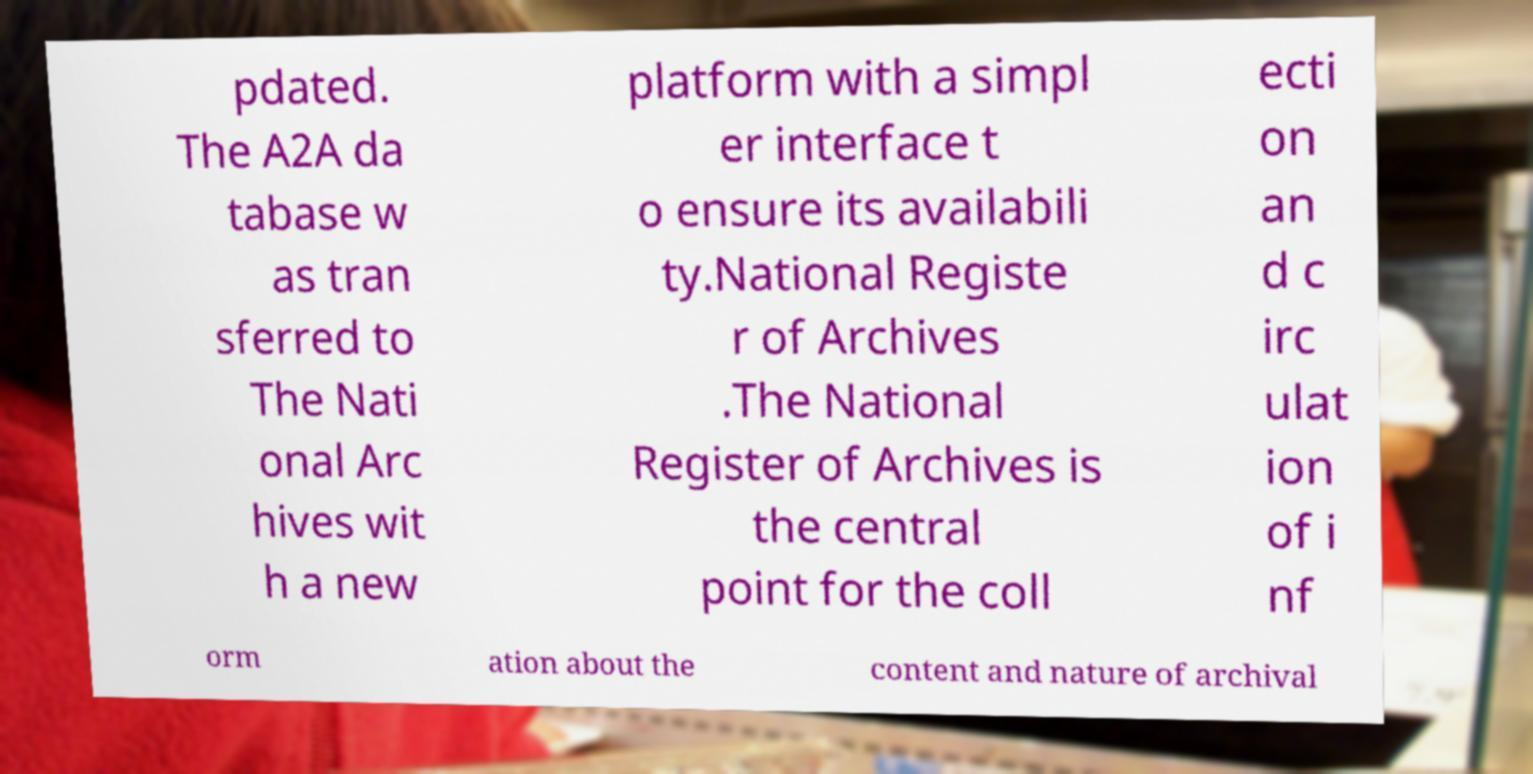I need the written content from this picture converted into text. Can you do that? pdated. The A2A da tabase w as tran sferred to The Nati onal Arc hives wit h a new platform with a simpl er interface t o ensure its availabili ty.National Registe r of Archives .The National Register of Archives is the central point for the coll ecti on an d c irc ulat ion of i nf orm ation about the content and nature of archival 